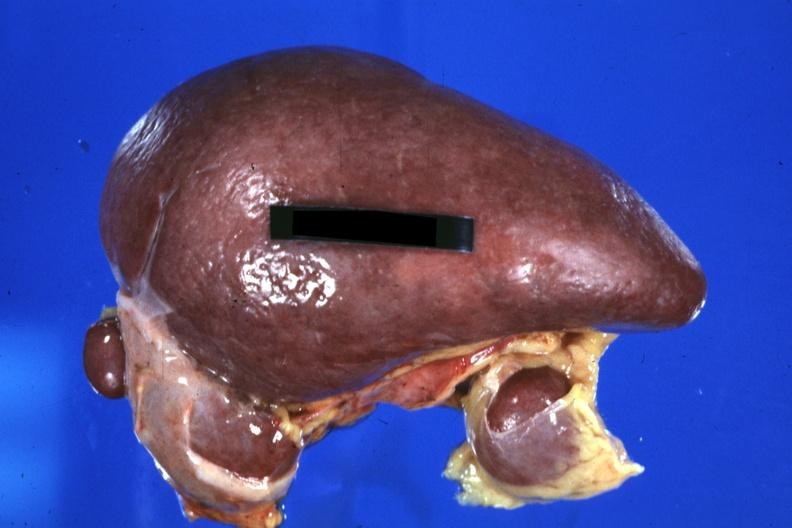s hematologic present?
Answer the question using a single word or phrase. Yes 